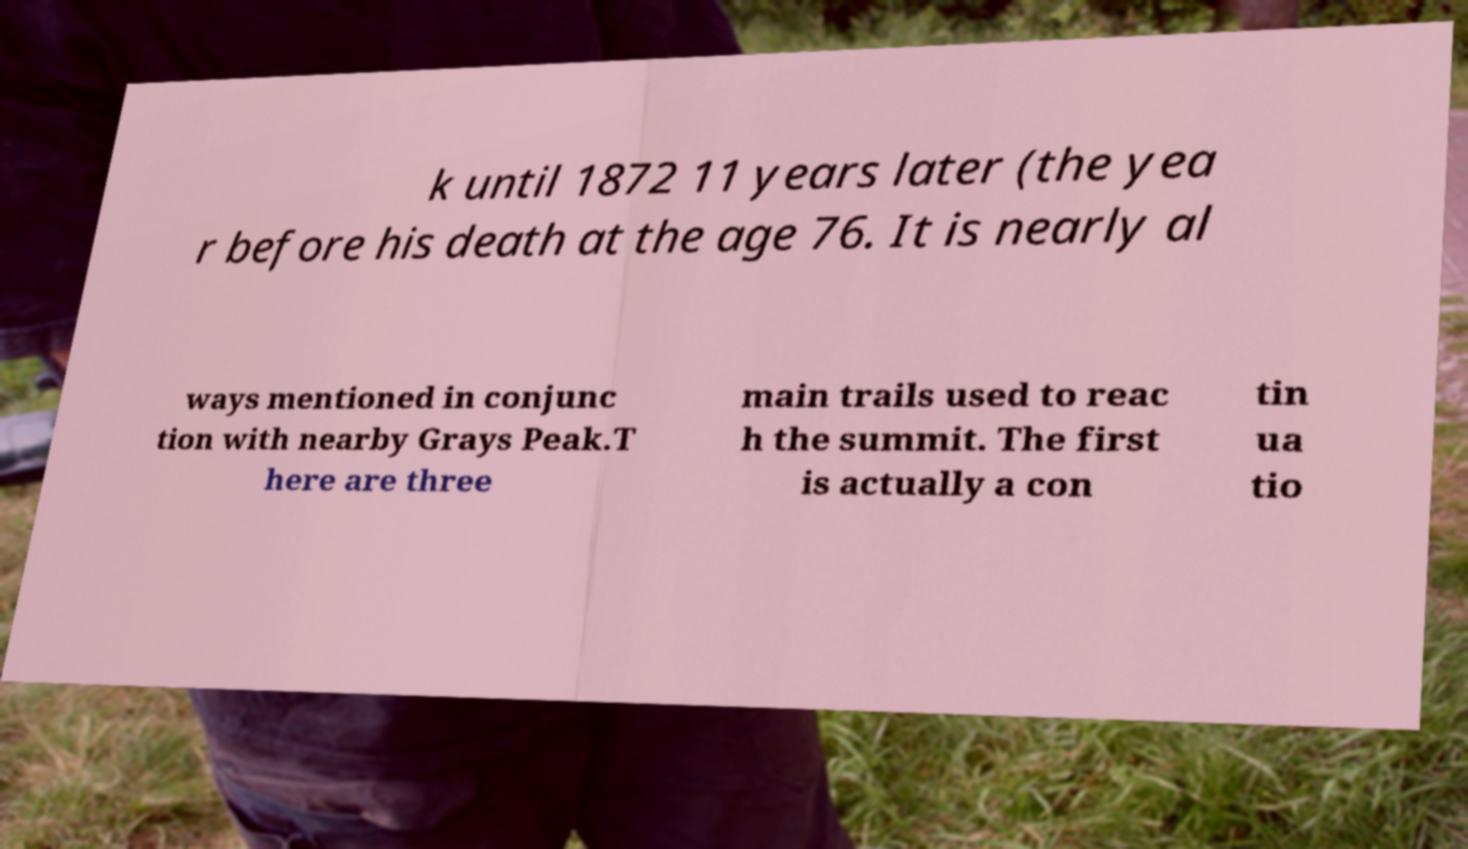I need the written content from this picture converted into text. Can you do that? k until 1872 11 years later (the yea r before his death at the age 76. It is nearly al ways mentioned in conjunc tion with nearby Grays Peak.T here are three main trails used to reac h the summit. The first is actually a con tin ua tio 